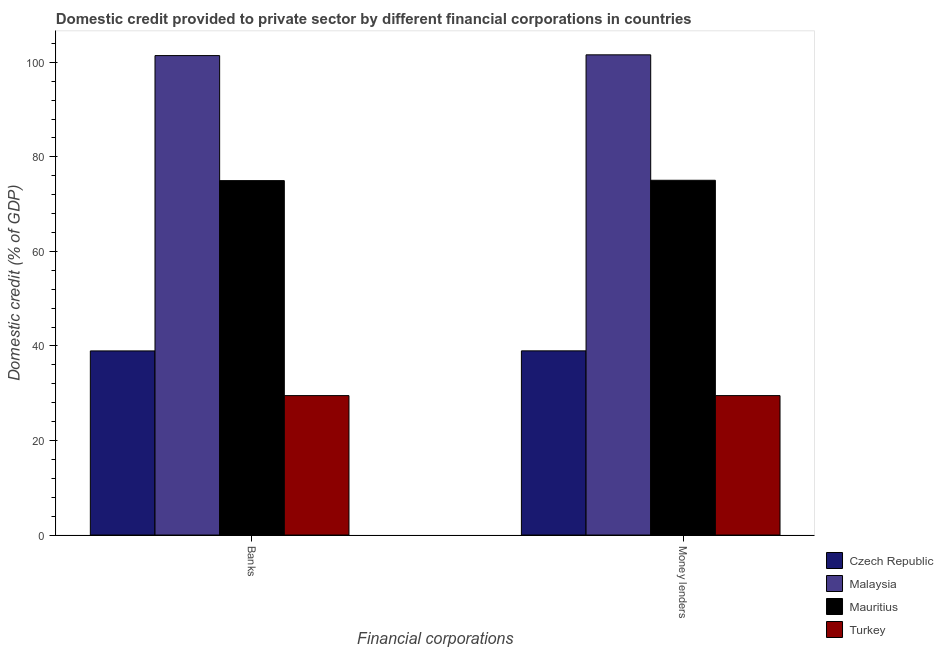How many groups of bars are there?
Your answer should be very brief. 2. Are the number of bars per tick equal to the number of legend labels?
Keep it short and to the point. Yes. Are the number of bars on each tick of the X-axis equal?
Keep it short and to the point. Yes. How many bars are there on the 1st tick from the left?
Offer a terse response. 4. What is the label of the 1st group of bars from the left?
Ensure brevity in your answer.  Banks. What is the domestic credit provided by money lenders in Turkey?
Your response must be concise. 29.5. Across all countries, what is the maximum domestic credit provided by banks?
Your answer should be very brief. 101.42. Across all countries, what is the minimum domestic credit provided by banks?
Keep it short and to the point. 29.5. In which country was the domestic credit provided by banks maximum?
Provide a succinct answer. Malaysia. In which country was the domestic credit provided by banks minimum?
Ensure brevity in your answer.  Turkey. What is the total domestic credit provided by money lenders in the graph?
Your answer should be compact. 245.08. What is the difference between the domestic credit provided by banks in Malaysia and that in Turkey?
Ensure brevity in your answer.  71.92. What is the difference between the domestic credit provided by banks in Czech Republic and the domestic credit provided by money lenders in Malaysia?
Ensure brevity in your answer.  -62.63. What is the average domestic credit provided by money lenders per country?
Your answer should be very brief. 61.27. What is the difference between the domestic credit provided by money lenders and domestic credit provided by banks in Mauritius?
Provide a succinct answer. 0.08. What is the ratio of the domestic credit provided by banks in Turkey to that in Czech Republic?
Offer a terse response. 0.76. In how many countries, is the domestic credit provided by money lenders greater than the average domestic credit provided by money lenders taken over all countries?
Make the answer very short. 2. What does the 3rd bar from the left in Money lenders represents?
Provide a short and direct response. Mauritius. What does the 2nd bar from the right in Money lenders represents?
Provide a succinct answer. Mauritius. Are all the bars in the graph horizontal?
Ensure brevity in your answer.  No. How many countries are there in the graph?
Give a very brief answer. 4. What is the difference between two consecutive major ticks on the Y-axis?
Keep it short and to the point. 20. Are the values on the major ticks of Y-axis written in scientific E-notation?
Ensure brevity in your answer.  No. Does the graph contain any zero values?
Your answer should be compact. No. Where does the legend appear in the graph?
Give a very brief answer. Bottom right. What is the title of the graph?
Provide a short and direct response. Domestic credit provided to private sector by different financial corporations in countries. What is the label or title of the X-axis?
Offer a terse response. Financial corporations. What is the label or title of the Y-axis?
Your answer should be compact. Domestic credit (% of GDP). What is the Domestic credit (% of GDP) in Czech Republic in Banks?
Your answer should be very brief. 38.95. What is the Domestic credit (% of GDP) in Malaysia in Banks?
Your answer should be very brief. 101.42. What is the Domestic credit (% of GDP) in Mauritius in Banks?
Your answer should be compact. 74.97. What is the Domestic credit (% of GDP) of Turkey in Banks?
Provide a short and direct response. 29.5. What is the Domestic credit (% of GDP) in Czech Republic in Money lenders?
Offer a very short reply. 38.96. What is the Domestic credit (% of GDP) in Malaysia in Money lenders?
Your response must be concise. 101.58. What is the Domestic credit (% of GDP) in Mauritius in Money lenders?
Ensure brevity in your answer.  75.04. What is the Domestic credit (% of GDP) of Turkey in Money lenders?
Ensure brevity in your answer.  29.5. Across all Financial corporations, what is the maximum Domestic credit (% of GDP) of Czech Republic?
Ensure brevity in your answer.  38.96. Across all Financial corporations, what is the maximum Domestic credit (% of GDP) in Malaysia?
Offer a terse response. 101.58. Across all Financial corporations, what is the maximum Domestic credit (% of GDP) in Mauritius?
Offer a terse response. 75.04. Across all Financial corporations, what is the maximum Domestic credit (% of GDP) in Turkey?
Make the answer very short. 29.5. Across all Financial corporations, what is the minimum Domestic credit (% of GDP) in Czech Republic?
Ensure brevity in your answer.  38.95. Across all Financial corporations, what is the minimum Domestic credit (% of GDP) in Malaysia?
Offer a very short reply. 101.42. Across all Financial corporations, what is the minimum Domestic credit (% of GDP) in Mauritius?
Ensure brevity in your answer.  74.97. Across all Financial corporations, what is the minimum Domestic credit (% of GDP) of Turkey?
Your answer should be very brief. 29.5. What is the total Domestic credit (% of GDP) of Czech Republic in the graph?
Keep it short and to the point. 77.91. What is the total Domestic credit (% of GDP) of Malaysia in the graph?
Provide a succinct answer. 203. What is the total Domestic credit (% of GDP) of Mauritius in the graph?
Provide a succinct answer. 150.01. What is the total Domestic credit (% of GDP) of Turkey in the graph?
Your answer should be compact. 58.99. What is the difference between the Domestic credit (% of GDP) in Czech Republic in Banks and that in Money lenders?
Your answer should be compact. -0.01. What is the difference between the Domestic credit (% of GDP) of Malaysia in Banks and that in Money lenders?
Give a very brief answer. -0.16. What is the difference between the Domestic credit (% of GDP) in Mauritius in Banks and that in Money lenders?
Give a very brief answer. -0.08. What is the difference between the Domestic credit (% of GDP) of Czech Republic in Banks and the Domestic credit (% of GDP) of Malaysia in Money lenders?
Give a very brief answer. -62.63. What is the difference between the Domestic credit (% of GDP) in Czech Republic in Banks and the Domestic credit (% of GDP) in Mauritius in Money lenders?
Your response must be concise. -36.1. What is the difference between the Domestic credit (% of GDP) in Czech Republic in Banks and the Domestic credit (% of GDP) in Turkey in Money lenders?
Your answer should be compact. 9.45. What is the difference between the Domestic credit (% of GDP) of Malaysia in Banks and the Domestic credit (% of GDP) of Mauritius in Money lenders?
Provide a succinct answer. 26.38. What is the difference between the Domestic credit (% of GDP) of Malaysia in Banks and the Domestic credit (% of GDP) of Turkey in Money lenders?
Offer a terse response. 71.92. What is the difference between the Domestic credit (% of GDP) in Mauritius in Banks and the Domestic credit (% of GDP) in Turkey in Money lenders?
Your answer should be very brief. 45.47. What is the average Domestic credit (% of GDP) in Czech Republic per Financial corporations?
Make the answer very short. 38.95. What is the average Domestic credit (% of GDP) in Malaysia per Financial corporations?
Make the answer very short. 101.5. What is the average Domestic credit (% of GDP) of Mauritius per Financial corporations?
Your answer should be compact. 75.01. What is the average Domestic credit (% of GDP) of Turkey per Financial corporations?
Give a very brief answer. 29.5. What is the difference between the Domestic credit (% of GDP) in Czech Republic and Domestic credit (% of GDP) in Malaysia in Banks?
Offer a terse response. -62.47. What is the difference between the Domestic credit (% of GDP) in Czech Republic and Domestic credit (% of GDP) in Mauritius in Banks?
Offer a terse response. -36.02. What is the difference between the Domestic credit (% of GDP) in Czech Republic and Domestic credit (% of GDP) in Turkey in Banks?
Ensure brevity in your answer.  9.45. What is the difference between the Domestic credit (% of GDP) in Malaysia and Domestic credit (% of GDP) in Mauritius in Banks?
Your answer should be very brief. 26.45. What is the difference between the Domestic credit (% of GDP) of Malaysia and Domestic credit (% of GDP) of Turkey in Banks?
Provide a short and direct response. 71.92. What is the difference between the Domestic credit (% of GDP) of Mauritius and Domestic credit (% of GDP) of Turkey in Banks?
Provide a short and direct response. 45.47. What is the difference between the Domestic credit (% of GDP) in Czech Republic and Domestic credit (% of GDP) in Malaysia in Money lenders?
Make the answer very short. -62.62. What is the difference between the Domestic credit (% of GDP) of Czech Republic and Domestic credit (% of GDP) of Mauritius in Money lenders?
Give a very brief answer. -36.08. What is the difference between the Domestic credit (% of GDP) in Czech Republic and Domestic credit (% of GDP) in Turkey in Money lenders?
Keep it short and to the point. 9.47. What is the difference between the Domestic credit (% of GDP) in Malaysia and Domestic credit (% of GDP) in Mauritius in Money lenders?
Make the answer very short. 26.54. What is the difference between the Domestic credit (% of GDP) in Malaysia and Domestic credit (% of GDP) in Turkey in Money lenders?
Your response must be concise. 72.08. What is the difference between the Domestic credit (% of GDP) in Mauritius and Domestic credit (% of GDP) in Turkey in Money lenders?
Make the answer very short. 45.55. What is the ratio of the Domestic credit (% of GDP) of Mauritius in Banks to that in Money lenders?
Your answer should be very brief. 1. What is the ratio of the Domestic credit (% of GDP) in Turkey in Banks to that in Money lenders?
Offer a very short reply. 1. What is the difference between the highest and the second highest Domestic credit (% of GDP) of Czech Republic?
Provide a succinct answer. 0.01. What is the difference between the highest and the second highest Domestic credit (% of GDP) in Malaysia?
Offer a very short reply. 0.16. What is the difference between the highest and the second highest Domestic credit (% of GDP) of Mauritius?
Your answer should be very brief. 0.08. What is the difference between the highest and the lowest Domestic credit (% of GDP) of Czech Republic?
Your answer should be very brief. 0.01. What is the difference between the highest and the lowest Domestic credit (% of GDP) in Malaysia?
Provide a succinct answer. 0.16. What is the difference between the highest and the lowest Domestic credit (% of GDP) of Mauritius?
Offer a very short reply. 0.08. What is the difference between the highest and the lowest Domestic credit (% of GDP) of Turkey?
Provide a succinct answer. 0. 